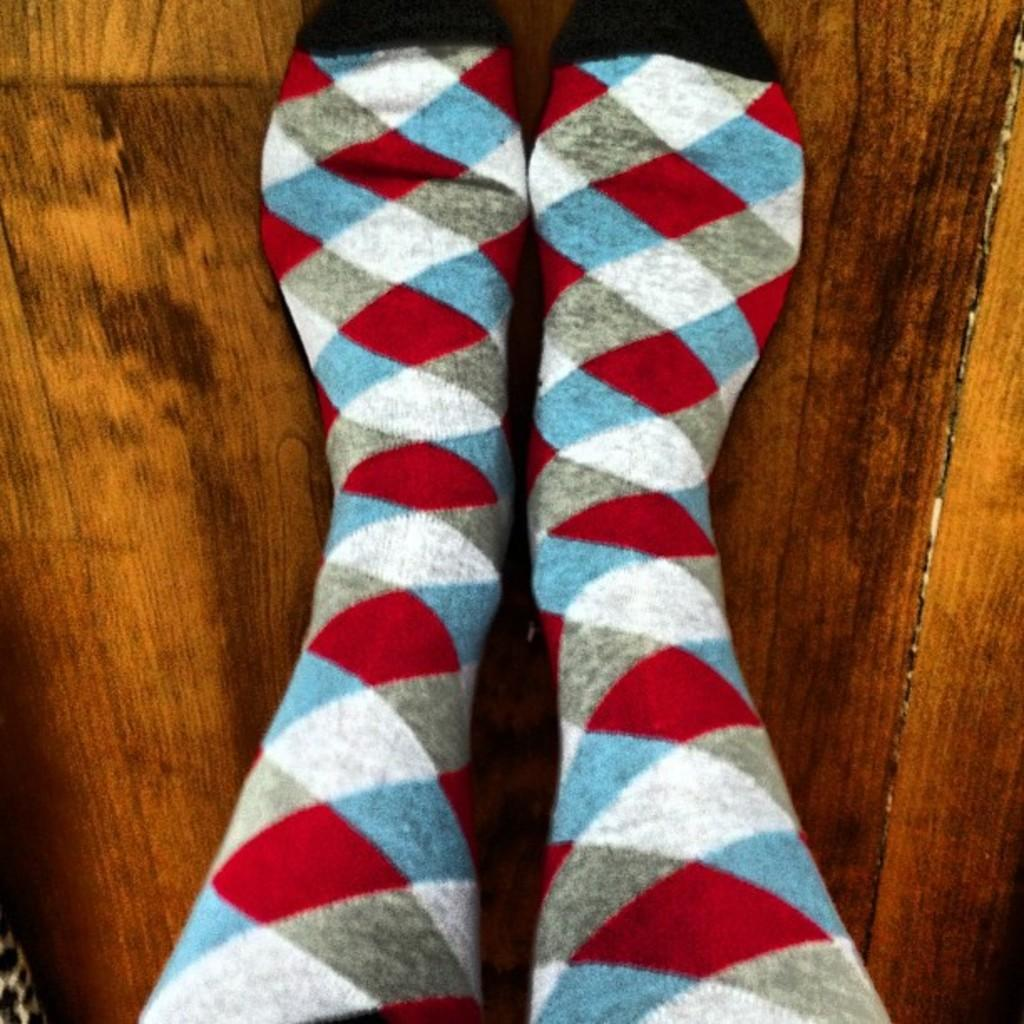What part of a person can be seen in the image? There are legs of a person visible in the image. What type of clothing is the person wearing on their feet? The person is wearing socks. What material is the surface that the person's legs are resting on? There is a wooden surface in the image. What type of cart is being driven by the governor in the image? There is no governor or cart present in the image. How many flies can be seen buzzing around the person's legs in the image? There are no flies present in the image. 